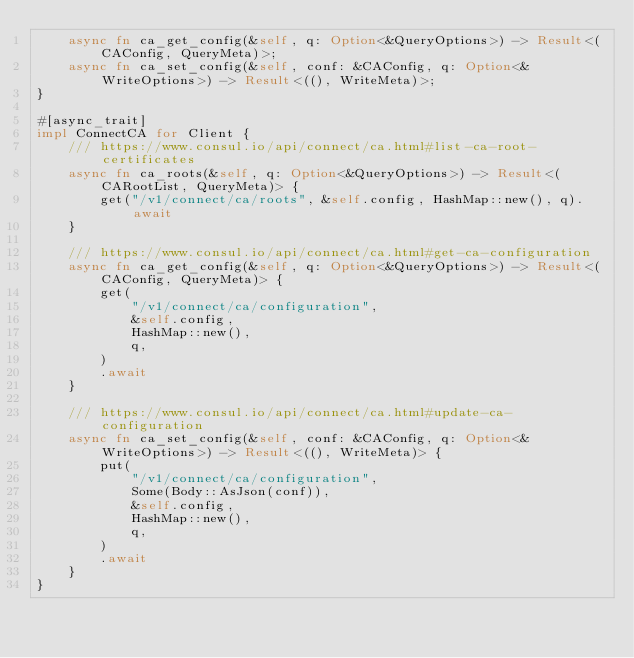<code> <loc_0><loc_0><loc_500><loc_500><_Rust_>    async fn ca_get_config(&self, q: Option<&QueryOptions>) -> Result<(CAConfig, QueryMeta)>;
    async fn ca_set_config(&self, conf: &CAConfig, q: Option<&WriteOptions>) -> Result<((), WriteMeta)>;
}

#[async_trait]
impl ConnectCA for Client {
    /// https://www.consul.io/api/connect/ca.html#list-ca-root-certificates
    async fn ca_roots(&self, q: Option<&QueryOptions>) -> Result<(CARootList, QueryMeta)> {
        get("/v1/connect/ca/roots", &self.config, HashMap::new(), q).await
    }

    /// https://www.consul.io/api/connect/ca.html#get-ca-configuration
    async fn ca_get_config(&self, q: Option<&QueryOptions>) -> Result<(CAConfig, QueryMeta)> {
        get(
            "/v1/connect/ca/configuration",
            &self.config,
            HashMap::new(),
            q,
        )
        .await
    }

    /// https://www.consul.io/api/connect/ca.html#update-ca-configuration
    async fn ca_set_config(&self, conf: &CAConfig, q: Option<&WriteOptions>) -> Result<((), WriteMeta)> {
        put(
            "/v1/connect/ca/configuration",
            Some(Body::AsJson(conf)),
            &self.config,
            HashMap::new(),
            q,
        )
        .await
    }
}
</code> 